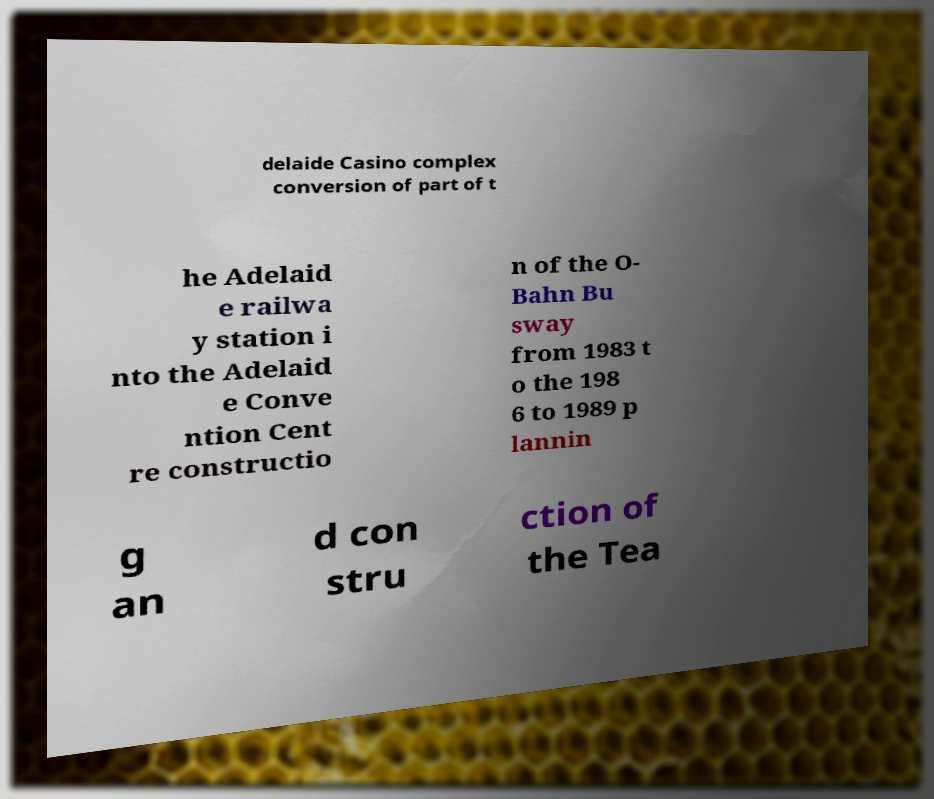What messages or text are displayed in this image? I need them in a readable, typed format. delaide Casino complex conversion of part of t he Adelaid e railwa y station i nto the Adelaid e Conve ntion Cent re constructio n of the O- Bahn Bu sway from 1983 t o the 198 6 to 1989 p lannin g an d con stru ction of the Tea 